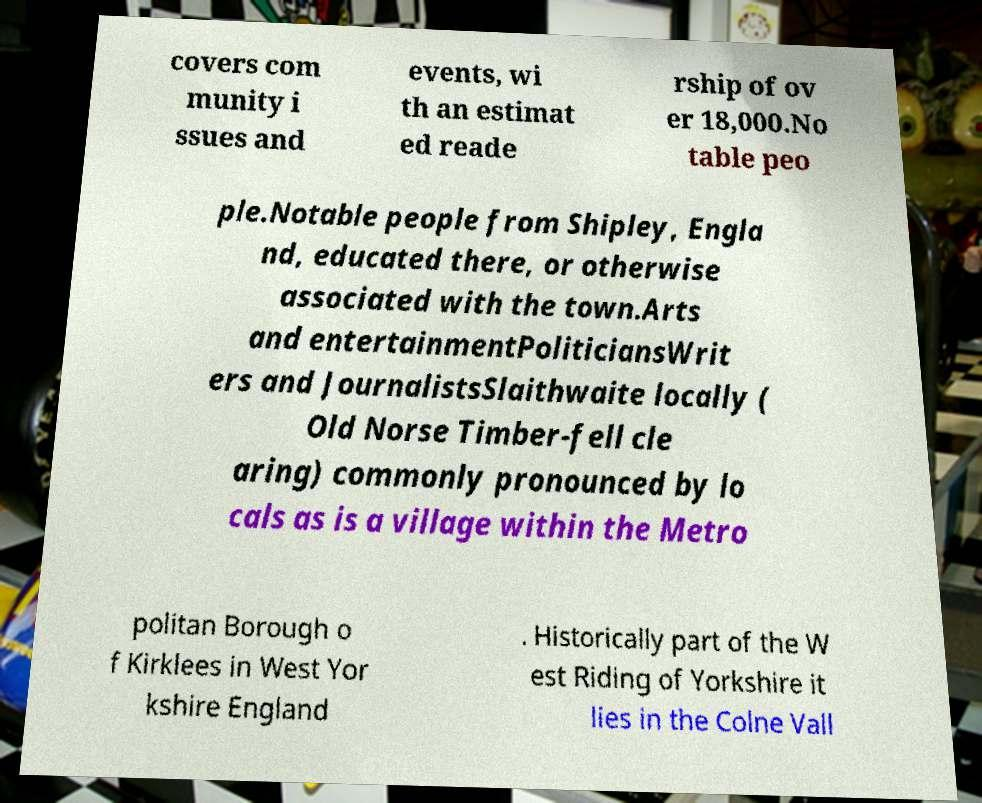Can you accurately transcribe the text from the provided image for me? covers com munity i ssues and events, wi th an estimat ed reade rship of ov er 18,000.No table peo ple.Notable people from Shipley, Engla nd, educated there, or otherwise associated with the town.Arts and entertainmentPoliticiansWrit ers and JournalistsSlaithwaite locally ( Old Norse Timber-fell cle aring) commonly pronounced by lo cals as is a village within the Metro politan Borough o f Kirklees in West Yor kshire England . Historically part of the W est Riding of Yorkshire it lies in the Colne Vall 